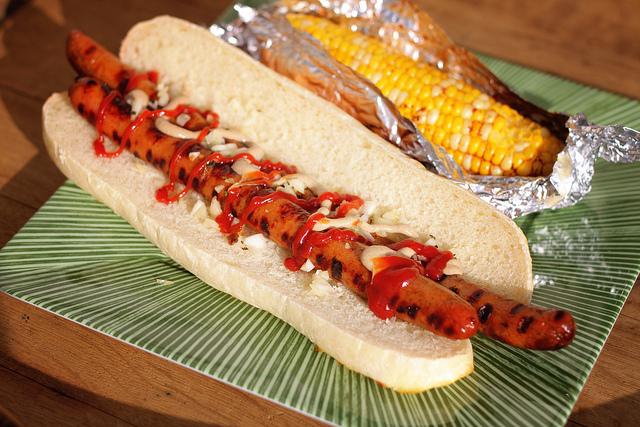Is there aluminum foil?
Concise answer only. Yes. What is the shape of the ketchup on the hot dog?
Keep it brief. Zig zag. Why do you think the intended consumer of this meal might be very hungry?
Write a very short answer. Yes. What kind of meat?
Write a very short answer. Hot dog. 